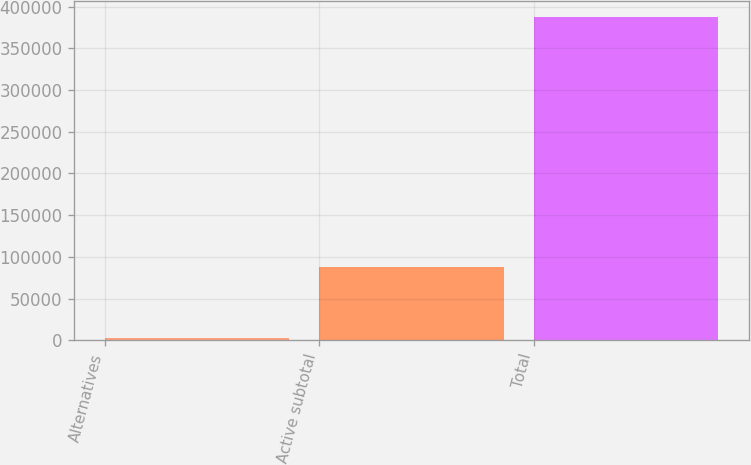<chart> <loc_0><loc_0><loc_500><loc_500><bar_chart><fcel>Alternatives<fcel>Active subtotal<fcel>Total<nl><fcel>2771<fcel>88155<fcel>387492<nl></chart> 